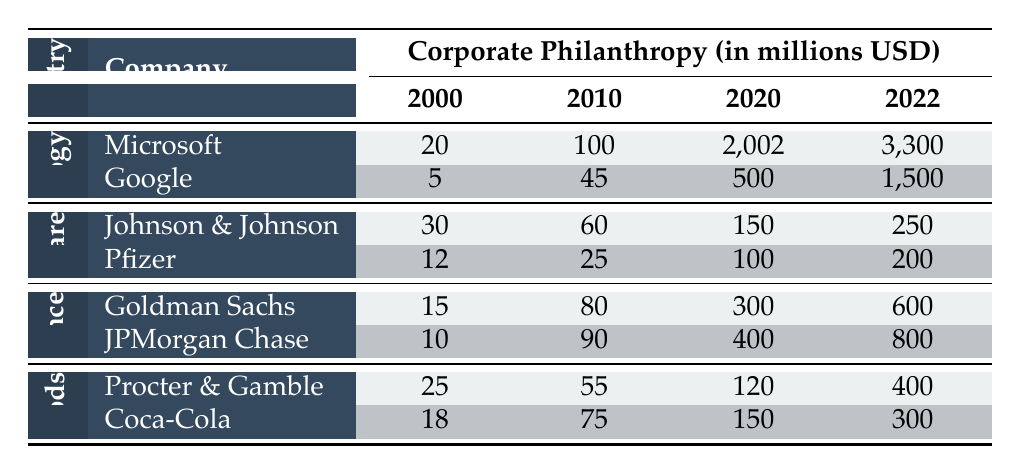What was the corporate philanthropy amount for Microsoft in 2022? The table shows that the corporate philanthropy amount for Microsoft in the year 2022 is 3,300 million USD.
Answer: 3,300 million USD Which company had the highest corporate philanthropy contribution in 2020? By examining the 2020 values for each company, Microsoft contributed 2,002 million USD, which is the highest compared to the others: Google (500), Johnson & Johnson (150), Pfizer (100), Goldman Sachs (300), JPMorgan Chase (400), Procter & Gamble (120), and Coca-Cola (150).
Answer: Microsoft What was the total corporate philanthropy contribution from the Healthcare industry in 2022? For the Healthcare industry in 2022, the contributions are: Johnson & Johnson (250) and Pfizer (200). Summing these gives: 250 + 200 = 450 million USD.
Answer: 450 million USD Did Google increase its corporate philanthropy from 2010 to 2022? The contributions for Google were 45 million USD in 2010 and increased to 1,500 million USD in 2022, indicating an increase.
Answer: Yes What is the average corporate philanthropy contribution for JPMorgan Chase over the years shown? To calculate the average, sum the contributions: (10 + 90 + 400 + 800) = 1300 million USD. Then, divide by the number of years (4): 1300 / 4 = 325 million USD.
Answer: 325 million USD Which industry saw the highest increase in corporate philanthropy from 2000 to 2022? Looking at the 2000 and 2022 contributions for each industry, Technology increased from 25 to 3,300 (3,275), Healthcare from 42 to 450 (408), Finance from 25 to 1,400 (1,375), and Consumer Goods from 43 to 700 (657). The Technology industry shows the largest increase of 3,275 million USD.
Answer: Technology What was the combined corporate philanthropy of Google and Microsoft in 2010? The contributions in 2010 were: Microsoft (100) and Google (45). Adding these gives: 100 + 45 = 145 million USD.
Answer: 145 million USD Was there any year when Coca-Cola's contributions were greater than Procter & Gamble's? By comparing their contributions across the years, Coca-Cola (18, 75, 150, 300) was never greater than Procter & Gamble (25, 55, 120, 400) in any of the years.
Answer: No 